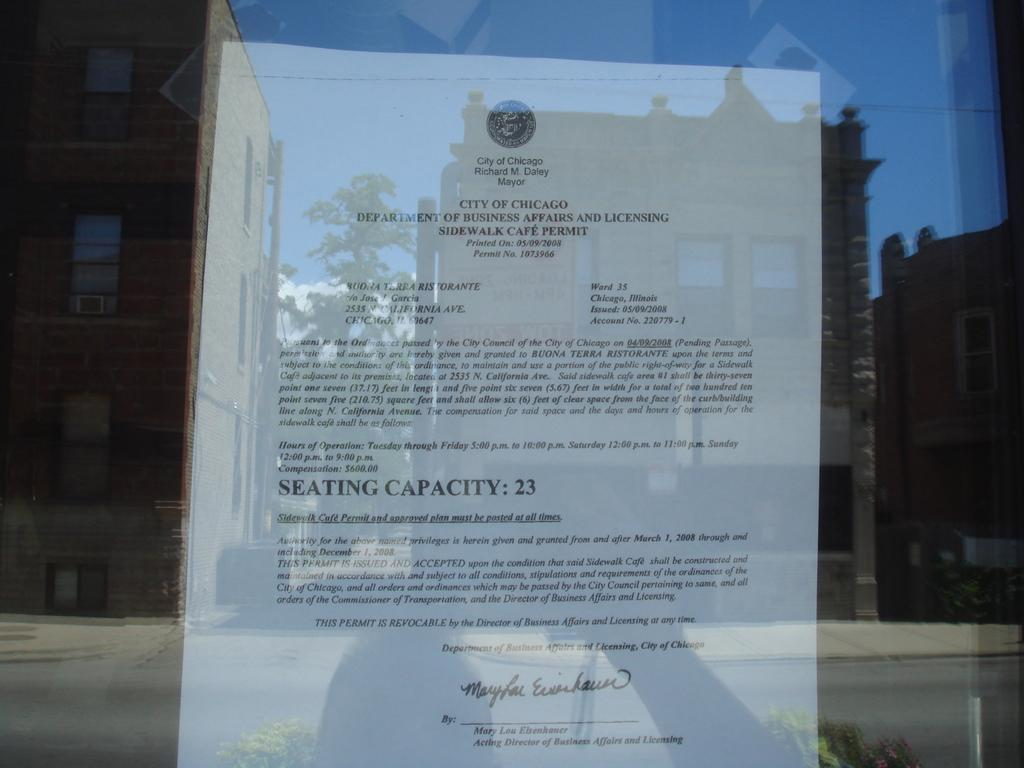What is the primary object in the image? There is a white paper in the image. How is the paper positioned in relation to another object? The paper is placed at the back of a glass. What can be found on the paper? There is text on the paper. Is there any blood visible on the paper in the image? No, there is no blood present on the paper in the image. Are there any chickens depicted on the paper in the image? No, there are no chickens depicted on the paper in the image. 